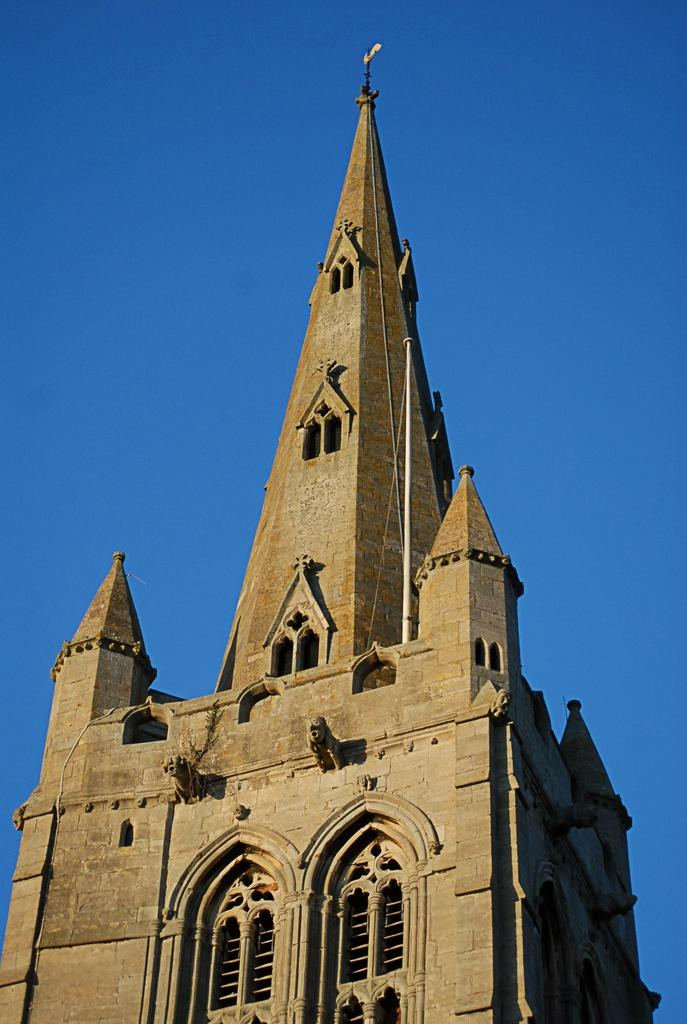What type of structure is present in the image? There is a building in the image. What feature can be seen on the building? There is a pole on the building. What is attached to the pole? There is a board on the pole. What is visible at the top of the image? The sky is visible at the top of the image. Can you tell me how many waves are crashing against the building in the image? There are no waves present in the image; it features a building with a pole and a board. What type of drink is being served by the representative in the image? There is no representative or drink present in the image. 